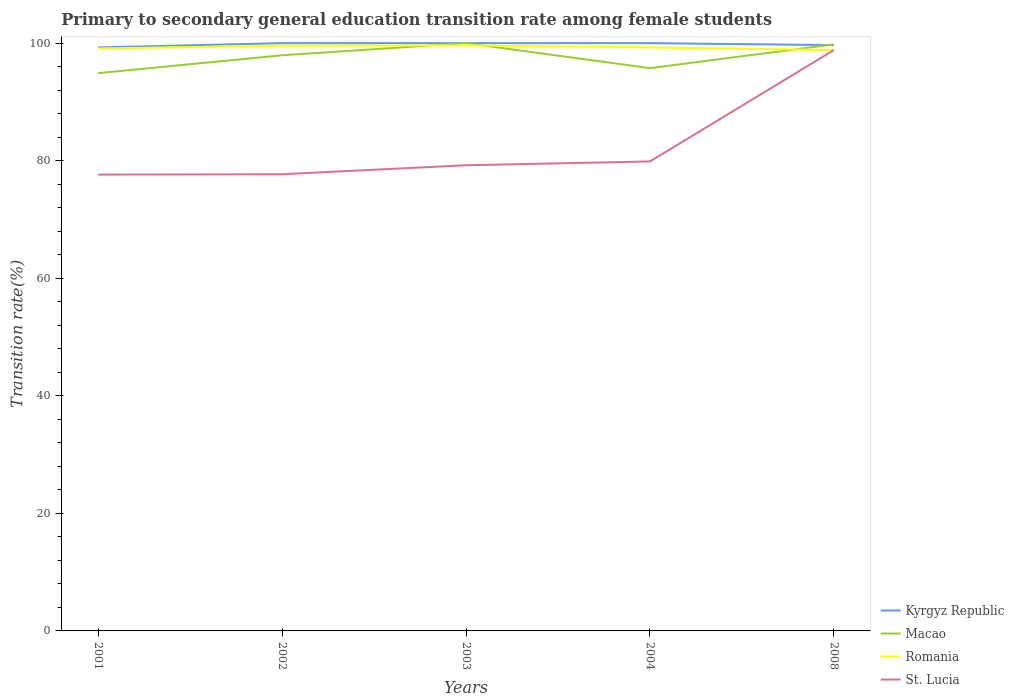Does the line corresponding to Romania intersect with the line corresponding to St. Lucia?
Make the answer very short. Yes. Across all years, what is the maximum transition rate in Macao?
Provide a succinct answer. 94.9. What is the total transition rate in Kyrgyz Republic in the graph?
Offer a terse response. -0.73. What is the difference between the highest and the second highest transition rate in Romania?
Give a very brief answer. 0.8. What is the difference between the highest and the lowest transition rate in Macao?
Offer a terse response. 3. How many years are there in the graph?
Your answer should be compact. 5. Does the graph contain any zero values?
Your answer should be compact. No. Where does the legend appear in the graph?
Offer a terse response. Bottom right. How many legend labels are there?
Make the answer very short. 4. How are the legend labels stacked?
Offer a very short reply. Vertical. What is the title of the graph?
Keep it short and to the point. Primary to secondary general education transition rate among female students. Does "Russian Federation" appear as one of the legend labels in the graph?
Your answer should be compact. No. What is the label or title of the Y-axis?
Make the answer very short. Transition rate(%). What is the Transition rate(%) of Kyrgyz Republic in 2001?
Make the answer very short. 99.27. What is the Transition rate(%) in Macao in 2001?
Provide a succinct answer. 94.9. What is the Transition rate(%) in Romania in 2001?
Keep it short and to the point. 99.1. What is the Transition rate(%) in St. Lucia in 2001?
Your response must be concise. 77.64. What is the Transition rate(%) in Kyrgyz Republic in 2002?
Your answer should be compact. 100. What is the Transition rate(%) of Macao in 2002?
Make the answer very short. 97.94. What is the Transition rate(%) in Romania in 2002?
Offer a terse response. 99.56. What is the Transition rate(%) of St. Lucia in 2002?
Offer a very short reply. 77.7. What is the Transition rate(%) of Kyrgyz Republic in 2003?
Keep it short and to the point. 100. What is the Transition rate(%) of Macao in 2003?
Provide a succinct answer. 100. What is the Transition rate(%) of Romania in 2003?
Make the answer very short. 99.62. What is the Transition rate(%) in St. Lucia in 2003?
Your answer should be very brief. 79.23. What is the Transition rate(%) of Macao in 2004?
Your response must be concise. 95.75. What is the Transition rate(%) in Romania in 2004?
Your response must be concise. 99.28. What is the Transition rate(%) of St. Lucia in 2004?
Your answer should be compact. 79.87. What is the Transition rate(%) of Kyrgyz Republic in 2008?
Ensure brevity in your answer.  99.67. What is the Transition rate(%) of Macao in 2008?
Offer a very short reply. 99.79. What is the Transition rate(%) of Romania in 2008?
Offer a terse response. 98.82. What is the Transition rate(%) in St. Lucia in 2008?
Offer a very short reply. 98.82. Across all years, what is the maximum Transition rate(%) in Romania?
Keep it short and to the point. 99.62. Across all years, what is the maximum Transition rate(%) in St. Lucia?
Ensure brevity in your answer.  98.82. Across all years, what is the minimum Transition rate(%) in Kyrgyz Republic?
Your answer should be very brief. 99.27. Across all years, what is the minimum Transition rate(%) in Macao?
Offer a terse response. 94.9. Across all years, what is the minimum Transition rate(%) of Romania?
Your answer should be compact. 98.82. Across all years, what is the minimum Transition rate(%) of St. Lucia?
Offer a terse response. 77.64. What is the total Transition rate(%) in Kyrgyz Republic in the graph?
Offer a terse response. 498.94. What is the total Transition rate(%) in Macao in the graph?
Offer a terse response. 488.37. What is the total Transition rate(%) in Romania in the graph?
Your answer should be very brief. 496.39. What is the total Transition rate(%) of St. Lucia in the graph?
Your answer should be compact. 413.26. What is the difference between the Transition rate(%) of Kyrgyz Republic in 2001 and that in 2002?
Make the answer very short. -0.73. What is the difference between the Transition rate(%) in Macao in 2001 and that in 2002?
Offer a very short reply. -3.04. What is the difference between the Transition rate(%) of Romania in 2001 and that in 2002?
Offer a terse response. -0.47. What is the difference between the Transition rate(%) of St. Lucia in 2001 and that in 2002?
Make the answer very short. -0.06. What is the difference between the Transition rate(%) in Kyrgyz Republic in 2001 and that in 2003?
Provide a short and direct response. -0.73. What is the difference between the Transition rate(%) in Macao in 2001 and that in 2003?
Keep it short and to the point. -5.1. What is the difference between the Transition rate(%) of Romania in 2001 and that in 2003?
Your answer should be very brief. -0.52. What is the difference between the Transition rate(%) in St. Lucia in 2001 and that in 2003?
Provide a succinct answer. -1.59. What is the difference between the Transition rate(%) in Kyrgyz Republic in 2001 and that in 2004?
Give a very brief answer. -0.73. What is the difference between the Transition rate(%) of Macao in 2001 and that in 2004?
Your answer should be very brief. -0.85. What is the difference between the Transition rate(%) in Romania in 2001 and that in 2004?
Ensure brevity in your answer.  -0.18. What is the difference between the Transition rate(%) of St. Lucia in 2001 and that in 2004?
Your answer should be very brief. -2.24. What is the difference between the Transition rate(%) of Kyrgyz Republic in 2001 and that in 2008?
Keep it short and to the point. -0.4. What is the difference between the Transition rate(%) in Macao in 2001 and that in 2008?
Provide a short and direct response. -4.89. What is the difference between the Transition rate(%) in Romania in 2001 and that in 2008?
Make the answer very short. 0.28. What is the difference between the Transition rate(%) in St. Lucia in 2001 and that in 2008?
Your answer should be compact. -21.19. What is the difference between the Transition rate(%) of Macao in 2002 and that in 2003?
Make the answer very short. -2.06. What is the difference between the Transition rate(%) in Romania in 2002 and that in 2003?
Offer a terse response. -0.05. What is the difference between the Transition rate(%) in St. Lucia in 2002 and that in 2003?
Give a very brief answer. -1.52. What is the difference between the Transition rate(%) of Macao in 2002 and that in 2004?
Ensure brevity in your answer.  2.19. What is the difference between the Transition rate(%) in Romania in 2002 and that in 2004?
Offer a very short reply. 0.28. What is the difference between the Transition rate(%) in St. Lucia in 2002 and that in 2004?
Make the answer very short. -2.17. What is the difference between the Transition rate(%) in Kyrgyz Republic in 2002 and that in 2008?
Your answer should be compact. 0.33. What is the difference between the Transition rate(%) of Macao in 2002 and that in 2008?
Ensure brevity in your answer.  -1.85. What is the difference between the Transition rate(%) of Romania in 2002 and that in 2008?
Offer a very short reply. 0.74. What is the difference between the Transition rate(%) in St. Lucia in 2002 and that in 2008?
Provide a short and direct response. -21.12. What is the difference between the Transition rate(%) in Kyrgyz Republic in 2003 and that in 2004?
Your answer should be compact. 0. What is the difference between the Transition rate(%) in Macao in 2003 and that in 2004?
Ensure brevity in your answer.  4.25. What is the difference between the Transition rate(%) of Romania in 2003 and that in 2004?
Your answer should be compact. 0.33. What is the difference between the Transition rate(%) in St. Lucia in 2003 and that in 2004?
Provide a short and direct response. -0.65. What is the difference between the Transition rate(%) in Kyrgyz Republic in 2003 and that in 2008?
Give a very brief answer. 0.33. What is the difference between the Transition rate(%) in Macao in 2003 and that in 2008?
Your answer should be very brief. 0.21. What is the difference between the Transition rate(%) of Romania in 2003 and that in 2008?
Keep it short and to the point. 0.8. What is the difference between the Transition rate(%) in St. Lucia in 2003 and that in 2008?
Provide a succinct answer. -19.6. What is the difference between the Transition rate(%) in Kyrgyz Republic in 2004 and that in 2008?
Keep it short and to the point. 0.33. What is the difference between the Transition rate(%) in Macao in 2004 and that in 2008?
Your response must be concise. -4.04. What is the difference between the Transition rate(%) in Romania in 2004 and that in 2008?
Offer a terse response. 0.46. What is the difference between the Transition rate(%) of St. Lucia in 2004 and that in 2008?
Your answer should be very brief. -18.95. What is the difference between the Transition rate(%) of Kyrgyz Republic in 2001 and the Transition rate(%) of Macao in 2002?
Provide a succinct answer. 1.33. What is the difference between the Transition rate(%) of Kyrgyz Republic in 2001 and the Transition rate(%) of Romania in 2002?
Offer a terse response. -0.29. What is the difference between the Transition rate(%) of Kyrgyz Republic in 2001 and the Transition rate(%) of St. Lucia in 2002?
Give a very brief answer. 21.57. What is the difference between the Transition rate(%) of Macao in 2001 and the Transition rate(%) of Romania in 2002?
Your answer should be compact. -4.67. What is the difference between the Transition rate(%) of Macao in 2001 and the Transition rate(%) of St. Lucia in 2002?
Give a very brief answer. 17.2. What is the difference between the Transition rate(%) of Romania in 2001 and the Transition rate(%) of St. Lucia in 2002?
Offer a terse response. 21.4. What is the difference between the Transition rate(%) of Kyrgyz Republic in 2001 and the Transition rate(%) of Macao in 2003?
Provide a short and direct response. -0.73. What is the difference between the Transition rate(%) of Kyrgyz Republic in 2001 and the Transition rate(%) of Romania in 2003?
Keep it short and to the point. -0.35. What is the difference between the Transition rate(%) of Kyrgyz Republic in 2001 and the Transition rate(%) of St. Lucia in 2003?
Provide a short and direct response. 20.05. What is the difference between the Transition rate(%) in Macao in 2001 and the Transition rate(%) in Romania in 2003?
Give a very brief answer. -4.72. What is the difference between the Transition rate(%) in Macao in 2001 and the Transition rate(%) in St. Lucia in 2003?
Provide a short and direct response. 15.67. What is the difference between the Transition rate(%) in Romania in 2001 and the Transition rate(%) in St. Lucia in 2003?
Make the answer very short. 19.87. What is the difference between the Transition rate(%) in Kyrgyz Republic in 2001 and the Transition rate(%) in Macao in 2004?
Your answer should be very brief. 3.52. What is the difference between the Transition rate(%) of Kyrgyz Republic in 2001 and the Transition rate(%) of Romania in 2004?
Provide a short and direct response. -0.01. What is the difference between the Transition rate(%) in Kyrgyz Republic in 2001 and the Transition rate(%) in St. Lucia in 2004?
Make the answer very short. 19.4. What is the difference between the Transition rate(%) of Macao in 2001 and the Transition rate(%) of Romania in 2004?
Make the answer very short. -4.39. What is the difference between the Transition rate(%) of Macao in 2001 and the Transition rate(%) of St. Lucia in 2004?
Your response must be concise. 15.02. What is the difference between the Transition rate(%) of Romania in 2001 and the Transition rate(%) of St. Lucia in 2004?
Give a very brief answer. 19.22. What is the difference between the Transition rate(%) in Kyrgyz Republic in 2001 and the Transition rate(%) in Macao in 2008?
Give a very brief answer. -0.52. What is the difference between the Transition rate(%) of Kyrgyz Republic in 2001 and the Transition rate(%) of Romania in 2008?
Offer a very short reply. 0.45. What is the difference between the Transition rate(%) of Kyrgyz Republic in 2001 and the Transition rate(%) of St. Lucia in 2008?
Your answer should be compact. 0.45. What is the difference between the Transition rate(%) of Macao in 2001 and the Transition rate(%) of Romania in 2008?
Make the answer very short. -3.92. What is the difference between the Transition rate(%) in Macao in 2001 and the Transition rate(%) in St. Lucia in 2008?
Your answer should be compact. -3.93. What is the difference between the Transition rate(%) in Romania in 2001 and the Transition rate(%) in St. Lucia in 2008?
Keep it short and to the point. 0.28. What is the difference between the Transition rate(%) in Kyrgyz Republic in 2002 and the Transition rate(%) in Romania in 2003?
Give a very brief answer. 0.38. What is the difference between the Transition rate(%) of Kyrgyz Republic in 2002 and the Transition rate(%) of St. Lucia in 2003?
Keep it short and to the point. 20.77. What is the difference between the Transition rate(%) of Macao in 2002 and the Transition rate(%) of Romania in 2003?
Your response must be concise. -1.68. What is the difference between the Transition rate(%) in Macao in 2002 and the Transition rate(%) in St. Lucia in 2003?
Give a very brief answer. 18.71. What is the difference between the Transition rate(%) of Romania in 2002 and the Transition rate(%) of St. Lucia in 2003?
Provide a short and direct response. 20.34. What is the difference between the Transition rate(%) of Kyrgyz Republic in 2002 and the Transition rate(%) of Macao in 2004?
Offer a very short reply. 4.25. What is the difference between the Transition rate(%) in Kyrgyz Republic in 2002 and the Transition rate(%) in Romania in 2004?
Give a very brief answer. 0.72. What is the difference between the Transition rate(%) in Kyrgyz Republic in 2002 and the Transition rate(%) in St. Lucia in 2004?
Ensure brevity in your answer.  20.13. What is the difference between the Transition rate(%) of Macao in 2002 and the Transition rate(%) of Romania in 2004?
Your response must be concise. -1.35. What is the difference between the Transition rate(%) of Macao in 2002 and the Transition rate(%) of St. Lucia in 2004?
Your response must be concise. 18.06. What is the difference between the Transition rate(%) of Romania in 2002 and the Transition rate(%) of St. Lucia in 2004?
Your answer should be compact. 19.69. What is the difference between the Transition rate(%) in Kyrgyz Republic in 2002 and the Transition rate(%) in Macao in 2008?
Provide a succinct answer. 0.21. What is the difference between the Transition rate(%) in Kyrgyz Republic in 2002 and the Transition rate(%) in Romania in 2008?
Keep it short and to the point. 1.18. What is the difference between the Transition rate(%) in Kyrgyz Republic in 2002 and the Transition rate(%) in St. Lucia in 2008?
Your answer should be compact. 1.18. What is the difference between the Transition rate(%) in Macao in 2002 and the Transition rate(%) in Romania in 2008?
Offer a very short reply. -0.88. What is the difference between the Transition rate(%) of Macao in 2002 and the Transition rate(%) of St. Lucia in 2008?
Keep it short and to the point. -0.88. What is the difference between the Transition rate(%) of Romania in 2002 and the Transition rate(%) of St. Lucia in 2008?
Ensure brevity in your answer.  0.74. What is the difference between the Transition rate(%) in Kyrgyz Republic in 2003 and the Transition rate(%) in Macao in 2004?
Offer a terse response. 4.25. What is the difference between the Transition rate(%) in Kyrgyz Republic in 2003 and the Transition rate(%) in Romania in 2004?
Provide a short and direct response. 0.72. What is the difference between the Transition rate(%) of Kyrgyz Republic in 2003 and the Transition rate(%) of St. Lucia in 2004?
Provide a succinct answer. 20.13. What is the difference between the Transition rate(%) of Macao in 2003 and the Transition rate(%) of Romania in 2004?
Ensure brevity in your answer.  0.72. What is the difference between the Transition rate(%) in Macao in 2003 and the Transition rate(%) in St. Lucia in 2004?
Provide a succinct answer. 20.13. What is the difference between the Transition rate(%) of Romania in 2003 and the Transition rate(%) of St. Lucia in 2004?
Your answer should be compact. 19.74. What is the difference between the Transition rate(%) of Kyrgyz Republic in 2003 and the Transition rate(%) of Macao in 2008?
Keep it short and to the point. 0.21. What is the difference between the Transition rate(%) of Kyrgyz Republic in 2003 and the Transition rate(%) of Romania in 2008?
Ensure brevity in your answer.  1.18. What is the difference between the Transition rate(%) in Kyrgyz Republic in 2003 and the Transition rate(%) in St. Lucia in 2008?
Give a very brief answer. 1.18. What is the difference between the Transition rate(%) of Macao in 2003 and the Transition rate(%) of Romania in 2008?
Keep it short and to the point. 1.18. What is the difference between the Transition rate(%) in Macao in 2003 and the Transition rate(%) in St. Lucia in 2008?
Your answer should be very brief. 1.18. What is the difference between the Transition rate(%) of Romania in 2003 and the Transition rate(%) of St. Lucia in 2008?
Keep it short and to the point. 0.8. What is the difference between the Transition rate(%) of Kyrgyz Republic in 2004 and the Transition rate(%) of Macao in 2008?
Make the answer very short. 0.21. What is the difference between the Transition rate(%) of Kyrgyz Republic in 2004 and the Transition rate(%) of Romania in 2008?
Your response must be concise. 1.18. What is the difference between the Transition rate(%) of Kyrgyz Republic in 2004 and the Transition rate(%) of St. Lucia in 2008?
Ensure brevity in your answer.  1.18. What is the difference between the Transition rate(%) of Macao in 2004 and the Transition rate(%) of Romania in 2008?
Give a very brief answer. -3.07. What is the difference between the Transition rate(%) in Macao in 2004 and the Transition rate(%) in St. Lucia in 2008?
Offer a very short reply. -3.07. What is the difference between the Transition rate(%) of Romania in 2004 and the Transition rate(%) of St. Lucia in 2008?
Ensure brevity in your answer.  0.46. What is the average Transition rate(%) in Kyrgyz Republic per year?
Give a very brief answer. 99.79. What is the average Transition rate(%) in Macao per year?
Give a very brief answer. 97.67. What is the average Transition rate(%) of Romania per year?
Your response must be concise. 99.28. What is the average Transition rate(%) in St. Lucia per year?
Offer a terse response. 82.65. In the year 2001, what is the difference between the Transition rate(%) in Kyrgyz Republic and Transition rate(%) in Macao?
Ensure brevity in your answer.  4.38. In the year 2001, what is the difference between the Transition rate(%) in Kyrgyz Republic and Transition rate(%) in Romania?
Keep it short and to the point. 0.17. In the year 2001, what is the difference between the Transition rate(%) in Kyrgyz Republic and Transition rate(%) in St. Lucia?
Provide a succinct answer. 21.63. In the year 2001, what is the difference between the Transition rate(%) in Macao and Transition rate(%) in Romania?
Keep it short and to the point. -4.2. In the year 2001, what is the difference between the Transition rate(%) in Macao and Transition rate(%) in St. Lucia?
Make the answer very short. 17.26. In the year 2001, what is the difference between the Transition rate(%) in Romania and Transition rate(%) in St. Lucia?
Make the answer very short. 21.46. In the year 2002, what is the difference between the Transition rate(%) of Kyrgyz Republic and Transition rate(%) of Macao?
Keep it short and to the point. 2.06. In the year 2002, what is the difference between the Transition rate(%) of Kyrgyz Republic and Transition rate(%) of Romania?
Make the answer very short. 0.44. In the year 2002, what is the difference between the Transition rate(%) in Kyrgyz Republic and Transition rate(%) in St. Lucia?
Ensure brevity in your answer.  22.3. In the year 2002, what is the difference between the Transition rate(%) of Macao and Transition rate(%) of Romania?
Ensure brevity in your answer.  -1.63. In the year 2002, what is the difference between the Transition rate(%) of Macao and Transition rate(%) of St. Lucia?
Keep it short and to the point. 20.24. In the year 2002, what is the difference between the Transition rate(%) in Romania and Transition rate(%) in St. Lucia?
Your answer should be compact. 21.86. In the year 2003, what is the difference between the Transition rate(%) in Kyrgyz Republic and Transition rate(%) in Romania?
Give a very brief answer. 0.38. In the year 2003, what is the difference between the Transition rate(%) of Kyrgyz Republic and Transition rate(%) of St. Lucia?
Ensure brevity in your answer.  20.77. In the year 2003, what is the difference between the Transition rate(%) in Macao and Transition rate(%) in Romania?
Offer a very short reply. 0.38. In the year 2003, what is the difference between the Transition rate(%) of Macao and Transition rate(%) of St. Lucia?
Offer a terse response. 20.77. In the year 2003, what is the difference between the Transition rate(%) in Romania and Transition rate(%) in St. Lucia?
Provide a succinct answer. 20.39. In the year 2004, what is the difference between the Transition rate(%) of Kyrgyz Republic and Transition rate(%) of Macao?
Keep it short and to the point. 4.25. In the year 2004, what is the difference between the Transition rate(%) in Kyrgyz Republic and Transition rate(%) in Romania?
Give a very brief answer. 0.72. In the year 2004, what is the difference between the Transition rate(%) in Kyrgyz Republic and Transition rate(%) in St. Lucia?
Offer a very short reply. 20.13. In the year 2004, what is the difference between the Transition rate(%) of Macao and Transition rate(%) of Romania?
Ensure brevity in your answer.  -3.53. In the year 2004, what is the difference between the Transition rate(%) of Macao and Transition rate(%) of St. Lucia?
Your answer should be compact. 15.88. In the year 2004, what is the difference between the Transition rate(%) of Romania and Transition rate(%) of St. Lucia?
Provide a short and direct response. 19.41. In the year 2008, what is the difference between the Transition rate(%) in Kyrgyz Republic and Transition rate(%) in Macao?
Provide a short and direct response. -0.12. In the year 2008, what is the difference between the Transition rate(%) in Kyrgyz Republic and Transition rate(%) in Romania?
Give a very brief answer. 0.85. In the year 2008, what is the difference between the Transition rate(%) in Kyrgyz Republic and Transition rate(%) in St. Lucia?
Offer a terse response. 0.84. In the year 2008, what is the difference between the Transition rate(%) of Macao and Transition rate(%) of Romania?
Ensure brevity in your answer.  0.97. In the year 2008, what is the difference between the Transition rate(%) of Macao and Transition rate(%) of St. Lucia?
Provide a short and direct response. 0.97. In the year 2008, what is the difference between the Transition rate(%) in Romania and Transition rate(%) in St. Lucia?
Your answer should be very brief. -0. What is the ratio of the Transition rate(%) in Macao in 2001 to that in 2002?
Offer a terse response. 0.97. What is the ratio of the Transition rate(%) of St. Lucia in 2001 to that in 2002?
Your response must be concise. 1. What is the ratio of the Transition rate(%) in Kyrgyz Republic in 2001 to that in 2003?
Make the answer very short. 0.99. What is the ratio of the Transition rate(%) in Macao in 2001 to that in 2003?
Make the answer very short. 0.95. What is the ratio of the Transition rate(%) in Romania in 2001 to that in 2003?
Your response must be concise. 0.99. What is the ratio of the Transition rate(%) in Kyrgyz Republic in 2001 to that in 2004?
Offer a terse response. 0.99. What is the ratio of the Transition rate(%) of Romania in 2001 to that in 2004?
Provide a short and direct response. 1. What is the ratio of the Transition rate(%) of St. Lucia in 2001 to that in 2004?
Provide a succinct answer. 0.97. What is the ratio of the Transition rate(%) of Kyrgyz Republic in 2001 to that in 2008?
Ensure brevity in your answer.  1. What is the ratio of the Transition rate(%) of Macao in 2001 to that in 2008?
Offer a terse response. 0.95. What is the ratio of the Transition rate(%) of St. Lucia in 2001 to that in 2008?
Provide a short and direct response. 0.79. What is the ratio of the Transition rate(%) of Kyrgyz Republic in 2002 to that in 2003?
Ensure brevity in your answer.  1. What is the ratio of the Transition rate(%) of Macao in 2002 to that in 2003?
Keep it short and to the point. 0.98. What is the ratio of the Transition rate(%) in Romania in 2002 to that in 2003?
Offer a terse response. 1. What is the ratio of the Transition rate(%) of St. Lucia in 2002 to that in 2003?
Ensure brevity in your answer.  0.98. What is the ratio of the Transition rate(%) in Macao in 2002 to that in 2004?
Offer a terse response. 1.02. What is the ratio of the Transition rate(%) in Romania in 2002 to that in 2004?
Keep it short and to the point. 1. What is the ratio of the Transition rate(%) of St. Lucia in 2002 to that in 2004?
Give a very brief answer. 0.97. What is the ratio of the Transition rate(%) of Kyrgyz Republic in 2002 to that in 2008?
Provide a short and direct response. 1. What is the ratio of the Transition rate(%) in Macao in 2002 to that in 2008?
Your response must be concise. 0.98. What is the ratio of the Transition rate(%) in Romania in 2002 to that in 2008?
Your answer should be very brief. 1.01. What is the ratio of the Transition rate(%) of St. Lucia in 2002 to that in 2008?
Ensure brevity in your answer.  0.79. What is the ratio of the Transition rate(%) of Macao in 2003 to that in 2004?
Make the answer very short. 1.04. What is the ratio of the Transition rate(%) in Romania in 2003 to that in 2004?
Give a very brief answer. 1. What is the ratio of the Transition rate(%) of St. Lucia in 2003 to that in 2004?
Offer a terse response. 0.99. What is the ratio of the Transition rate(%) in Macao in 2003 to that in 2008?
Make the answer very short. 1. What is the ratio of the Transition rate(%) in Romania in 2003 to that in 2008?
Provide a succinct answer. 1.01. What is the ratio of the Transition rate(%) of St. Lucia in 2003 to that in 2008?
Your answer should be very brief. 0.8. What is the ratio of the Transition rate(%) in Macao in 2004 to that in 2008?
Give a very brief answer. 0.96. What is the ratio of the Transition rate(%) in St. Lucia in 2004 to that in 2008?
Your answer should be very brief. 0.81. What is the difference between the highest and the second highest Transition rate(%) in Macao?
Your answer should be very brief. 0.21. What is the difference between the highest and the second highest Transition rate(%) in Romania?
Keep it short and to the point. 0.05. What is the difference between the highest and the second highest Transition rate(%) of St. Lucia?
Your answer should be compact. 18.95. What is the difference between the highest and the lowest Transition rate(%) in Kyrgyz Republic?
Keep it short and to the point. 0.73. What is the difference between the highest and the lowest Transition rate(%) of Macao?
Offer a terse response. 5.1. What is the difference between the highest and the lowest Transition rate(%) of Romania?
Give a very brief answer. 0.8. What is the difference between the highest and the lowest Transition rate(%) in St. Lucia?
Give a very brief answer. 21.19. 